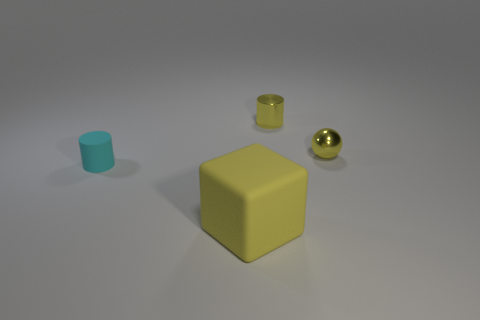What is the shape of the yellow matte object?
Your answer should be very brief. Cube. What number of large objects are behind the yellow shiny thing on the right side of the tiny cylinder behind the yellow ball?
Offer a very short reply. 0. What number of other things are made of the same material as the small yellow cylinder?
Provide a succinct answer. 1. What material is the yellow thing that is the same size as the yellow metallic cylinder?
Provide a succinct answer. Metal. There is a cylinder that is on the left side of the yellow metallic cylinder; is its color the same as the cylinder right of the cyan rubber object?
Ensure brevity in your answer.  No. Is there a big green metal object that has the same shape as the large matte thing?
Provide a short and direct response. No. There is a yellow metal thing that is the same size as the metal cylinder; what shape is it?
Your answer should be compact. Sphere. What number of small metal objects have the same color as the big matte object?
Your answer should be very brief. 2. How big is the cylinder behind the ball?
Provide a short and direct response. Small. What number of cylinders have the same size as the cyan matte thing?
Give a very brief answer. 1. 